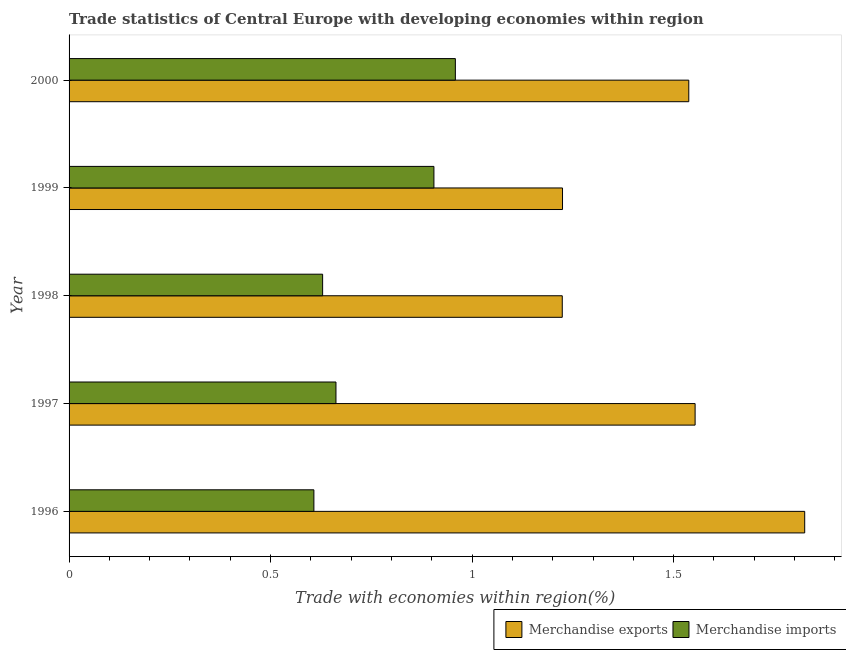How many different coloured bars are there?
Ensure brevity in your answer.  2. How many groups of bars are there?
Give a very brief answer. 5. Are the number of bars on each tick of the Y-axis equal?
Offer a terse response. Yes. In how many cases, is the number of bars for a given year not equal to the number of legend labels?
Give a very brief answer. 0. What is the merchandise exports in 1997?
Offer a terse response. 1.55. Across all years, what is the maximum merchandise imports?
Keep it short and to the point. 0.96. Across all years, what is the minimum merchandise exports?
Make the answer very short. 1.22. In which year was the merchandise exports maximum?
Make the answer very short. 1996. What is the total merchandise exports in the graph?
Ensure brevity in your answer.  7.36. What is the difference between the merchandise exports in 1996 and that in 1998?
Offer a very short reply. 0.6. What is the difference between the merchandise imports in 1997 and the merchandise exports in 2000?
Offer a very short reply. -0.88. What is the average merchandise exports per year?
Give a very brief answer. 1.47. In the year 1999, what is the difference between the merchandise exports and merchandise imports?
Provide a succinct answer. 0.32. In how many years, is the merchandise imports greater than 0.2 %?
Offer a terse response. 5. What is the ratio of the merchandise imports in 1996 to that in 1999?
Give a very brief answer. 0.67. Is the merchandise exports in 1998 less than that in 2000?
Ensure brevity in your answer.  Yes. Is the difference between the merchandise imports in 1996 and 1997 greater than the difference between the merchandise exports in 1996 and 1997?
Your response must be concise. No. What is the difference between the highest and the second highest merchandise imports?
Your answer should be compact. 0.05. What is the difference between the highest and the lowest merchandise imports?
Give a very brief answer. 0.35. Is the sum of the merchandise exports in 1999 and 2000 greater than the maximum merchandise imports across all years?
Your answer should be compact. Yes. Are all the bars in the graph horizontal?
Ensure brevity in your answer.  Yes. How many years are there in the graph?
Give a very brief answer. 5. What is the difference between two consecutive major ticks on the X-axis?
Your answer should be compact. 0.5. Are the values on the major ticks of X-axis written in scientific E-notation?
Your answer should be compact. No. What is the title of the graph?
Your response must be concise. Trade statistics of Central Europe with developing economies within region. What is the label or title of the X-axis?
Provide a succinct answer. Trade with economies within region(%). What is the label or title of the Y-axis?
Offer a terse response. Year. What is the Trade with economies within region(%) in Merchandise exports in 1996?
Offer a terse response. 1.83. What is the Trade with economies within region(%) in Merchandise imports in 1996?
Your answer should be very brief. 0.61. What is the Trade with economies within region(%) of Merchandise exports in 1997?
Provide a short and direct response. 1.55. What is the Trade with economies within region(%) in Merchandise imports in 1997?
Your answer should be compact. 0.66. What is the Trade with economies within region(%) of Merchandise exports in 1998?
Make the answer very short. 1.22. What is the Trade with economies within region(%) of Merchandise imports in 1998?
Offer a very short reply. 0.63. What is the Trade with economies within region(%) of Merchandise exports in 1999?
Give a very brief answer. 1.22. What is the Trade with economies within region(%) of Merchandise imports in 1999?
Offer a terse response. 0.91. What is the Trade with economies within region(%) of Merchandise exports in 2000?
Ensure brevity in your answer.  1.54. What is the Trade with economies within region(%) in Merchandise imports in 2000?
Provide a succinct answer. 0.96. Across all years, what is the maximum Trade with economies within region(%) of Merchandise exports?
Provide a short and direct response. 1.83. Across all years, what is the maximum Trade with economies within region(%) of Merchandise imports?
Keep it short and to the point. 0.96. Across all years, what is the minimum Trade with economies within region(%) of Merchandise exports?
Keep it short and to the point. 1.22. Across all years, what is the minimum Trade with economies within region(%) of Merchandise imports?
Your response must be concise. 0.61. What is the total Trade with economies within region(%) in Merchandise exports in the graph?
Your response must be concise. 7.36. What is the total Trade with economies within region(%) of Merchandise imports in the graph?
Offer a terse response. 3.76. What is the difference between the Trade with economies within region(%) of Merchandise exports in 1996 and that in 1997?
Your response must be concise. 0.27. What is the difference between the Trade with economies within region(%) of Merchandise imports in 1996 and that in 1997?
Your answer should be very brief. -0.05. What is the difference between the Trade with economies within region(%) of Merchandise exports in 1996 and that in 1998?
Your response must be concise. 0.6. What is the difference between the Trade with economies within region(%) of Merchandise imports in 1996 and that in 1998?
Offer a terse response. -0.02. What is the difference between the Trade with economies within region(%) in Merchandise exports in 1996 and that in 1999?
Make the answer very short. 0.6. What is the difference between the Trade with economies within region(%) of Merchandise imports in 1996 and that in 1999?
Your answer should be very brief. -0.3. What is the difference between the Trade with economies within region(%) of Merchandise exports in 1996 and that in 2000?
Give a very brief answer. 0.29. What is the difference between the Trade with economies within region(%) in Merchandise imports in 1996 and that in 2000?
Offer a very short reply. -0.35. What is the difference between the Trade with economies within region(%) in Merchandise exports in 1997 and that in 1998?
Your answer should be compact. 0.33. What is the difference between the Trade with economies within region(%) in Merchandise imports in 1997 and that in 1998?
Give a very brief answer. 0.03. What is the difference between the Trade with economies within region(%) in Merchandise exports in 1997 and that in 1999?
Your answer should be very brief. 0.33. What is the difference between the Trade with economies within region(%) of Merchandise imports in 1997 and that in 1999?
Give a very brief answer. -0.24. What is the difference between the Trade with economies within region(%) of Merchandise exports in 1997 and that in 2000?
Keep it short and to the point. 0.02. What is the difference between the Trade with economies within region(%) of Merchandise imports in 1997 and that in 2000?
Give a very brief answer. -0.3. What is the difference between the Trade with economies within region(%) in Merchandise exports in 1998 and that in 1999?
Your response must be concise. -0. What is the difference between the Trade with economies within region(%) in Merchandise imports in 1998 and that in 1999?
Offer a very short reply. -0.28. What is the difference between the Trade with economies within region(%) of Merchandise exports in 1998 and that in 2000?
Offer a terse response. -0.31. What is the difference between the Trade with economies within region(%) in Merchandise imports in 1998 and that in 2000?
Your response must be concise. -0.33. What is the difference between the Trade with economies within region(%) of Merchandise exports in 1999 and that in 2000?
Provide a succinct answer. -0.31. What is the difference between the Trade with economies within region(%) of Merchandise imports in 1999 and that in 2000?
Give a very brief answer. -0.05. What is the difference between the Trade with economies within region(%) of Merchandise exports in 1996 and the Trade with economies within region(%) of Merchandise imports in 1997?
Give a very brief answer. 1.16. What is the difference between the Trade with economies within region(%) in Merchandise exports in 1996 and the Trade with economies within region(%) in Merchandise imports in 1998?
Make the answer very short. 1.2. What is the difference between the Trade with economies within region(%) of Merchandise exports in 1996 and the Trade with economies within region(%) of Merchandise imports in 1999?
Ensure brevity in your answer.  0.92. What is the difference between the Trade with economies within region(%) in Merchandise exports in 1996 and the Trade with economies within region(%) in Merchandise imports in 2000?
Provide a short and direct response. 0.87. What is the difference between the Trade with economies within region(%) in Merchandise exports in 1997 and the Trade with economies within region(%) in Merchandise imports in 1998?
Offer a very short reply. 0.92. What is the difference between the Trade with economies within region(%) in Merchandise exports in 1997 and the Trade with economies within region(%) in Merchandise imports in 1999?
Your response must be concise. 0.65. What is the difference between the Trade with economies within region(%) in Merchandise exports in 1997 and the Trade with economies within region(%) in Merchandise imports in 2000?
Make the answer very short. 0.59. What is the difference between the Trade with economies within region(%) of Merchandise exports in 1998 and the Trade with economies within region(%) of Merchandise imports in 1999?
Offer a very short reply. 0.32. What is the difference between the Trade with economies within region(%) of Merchandise exports in 1998 and the Trade with economies within region(%) of Merchandise imports in 2000?
Your answer should be very brief. 0.27. What is the difference between the Trade with economies within region(%) in Merchandise exports in 1999 and the Trade with economies within region(%) in Merchandise imports in 2000?
Provide a succinct answer. 0.27. What is the average Trade with economies within region(%) of Merchandise exports per year?
Ensure brevity in your answer.  1.47. What is the average Trade with economies within region(%) of Merchandise imports per year?
Offer a terse response. 0.75. In the year 1996, what is the difference between the Trade with economies within region(%) of Merchandise exports and Trade with economies within region(%) of Merchandise imports?
Give a very brief answer. 1.22. In the year 1997, what is the difference between the Trade with economies within region(%) in Merchandise exports and Trade with economies within region(%) in Merchandise imports?
Your answer should be compact. 0.89. In the year 1998, what is the difference between the Trade with economies within region(%) of Merchandise exports and Trade with economies within region(%) of Merchandise imports?
Provide a succinct answer. 0.59. In the year 1999, what is the difference between the Trade with economies within region(%) in Merchandise exports and Trade with economies within region(%) in Merchandise imports?
Give a very brief answer. 0.32. In the year 2000, what is the difference between the Trade with economies within region(%) in Merchandise exports and Trade with economies within region(%) in Merchandise imports?
Keep it short and to the point. 0.58. What is the ratio of the Trade with economies within region(%) in Merchandise exports in 1996 to that in 1997?
Your answer should be very brief. 1.18. What is the ratio of the Trade with economies within region(%) of Merchandise imports in 1996 to that in 1997?
Ensure brevity in your answer.  0.92. What is the ratio of the Trade with economies within region(%) in Merchandise exports in 1996 to that in 1998?
Provide a short and direct response. 1.49. What is the ratio of the Trade with economies within region(%) of Merchandise imports in 1996 to that in 1998?
Offer a terse response. 0.97. What is the ratio of the Trade with economies within region(%) in Merchandise exports in 1996 to that in 1999?
Provide a short and direct response. 1.49. What is the ratio of the Trade with economies within region(%) in Merchandise imports in 1996 to that in 1999?
Offer a terse response. 0.67. What is the ratio of the Trade with economies within region(%) in Merchandise exports in 1996 to that in 2000?
Keep it short and to the point. 1.19. What is the ratio of the Trade with economies within region(%) in Merchandise imports in 1996 to that in 2000?
Provide a succinct answer. 0.63. What is the ratio of the Trade with economies within region(%) in Merchandise exports in 1997 to that in 1998?
Your answer should be very brief. 1.27. What is the ratio of the Trade with economies within region(%) of Merchandise imports in 1997 to that in 1998?
Make the answer very short. 1.05. What is the ratio of the Trade with economies within region(%) in Merchandise exports in 1997 to that in 1999?
Your answer should be very brief. 1.27. What is the ratio of the Trade with economies within region(%) of Merchandise imports in 1997 to that in 1999?
Ensure brevity in your answer.  0.73. What is the ratio of the Trade with economies within region(%) of Merchandise exports in 1997 to that in 2000?
Provide a succinct answer. 1.01. What is the ratio of the Trade with economies within region(%) of Merchandise imports in 1997 to that in 2000?
Provide a succinct answer. 0.69. What is the ratio of the Trade with economies within region(%) in Merchandise imports in 1998 to that in 1999?
Provide a succinct answer. 0.69. What is the ratio of the Trade with economies within region(%) of Merchandise exports in 1998 to that in 2000?
Your answer should be very brief. 0.8. What is the ratio of the Trade with economies within region(%) of Merchandise imports in 1998 to that in 2000?
Give a very brief answer. 0.66. What is the ratio of the Trade with economies within region(%) in Merchandise exports in 1999 to that in 2000?
Give a very brief answer. 0.8. What is the ratio of the Trade with economies within region(%) of Merchandise imports in 1999 to that in 2000?
Provide a short and direct response. 0.94. What is the difference between the highest and the second highest Trade with economies within region(%) in Merchandise exports?
Provide a short and direct response. 0.27. What is the difference between the highest and the second highest Trade with economies within region(%) of Merchandise imports?
Provide a succinct answer. 0.05. What is the difference between the highest and the lowest Trade with economies within region(%) in Merchandise exports?
Provide a short and direct response. 0.6. What is the difference between the highest and the lowest Trade with economies within region(%) in Merchandise imports?
Make the answer very short. 0.35. 